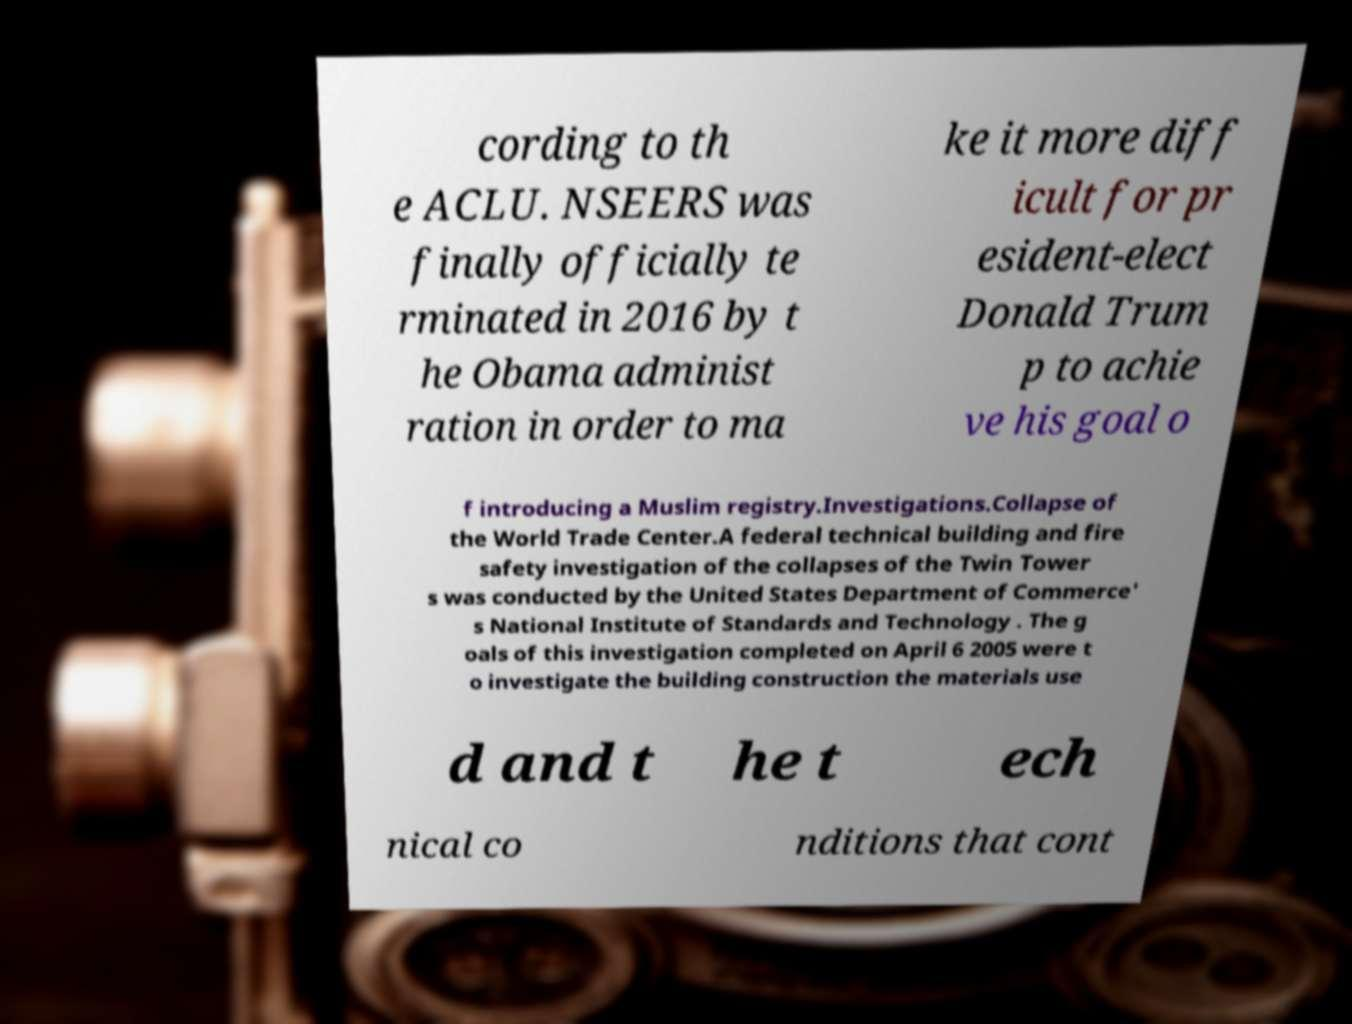Could you extract and type out the text from this image? cording to th e ACLU. NSEERS was finally officially te rminated in 2016 by t he Obama administ ration in order to ma ke it more diff icult for pr esident-elect Donald Trum p to achie ve his goal o f introducing a Muslim registry.Investigations.Collapse of the World Trade Center.A federal technical building and fire safety investigation of the collapses of the Twin Tower s was conducted by the United States Department of Commerce' s National Institute of Standards and Technology . The g oals of this investigation completed on April 6 2005 were t o investigate the building construction the materials use d and t he t ech nical co nditions that cont 